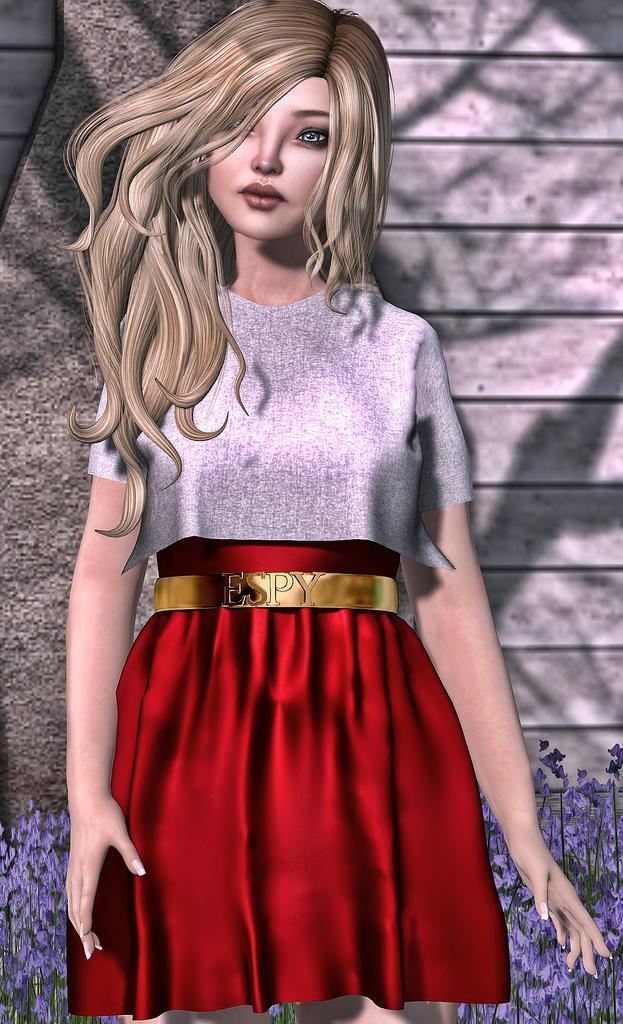How would you summarize this image in a sentence or two? In this animated image there is a barbie doll in the center and there are flowers and a wall in the background area. 